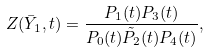Convert formula to latex. <formula><loc_0><loc_0><loc_500><loc_500>Z ( \bar { Y } _ { 1 } , t ) = \frac { P _ { 1 } ( t ) P _ { 3 } ( t ) } { P _ { 0 } ( t ) \tilde { P } _ { 2 } ( t ) P _ { 4 } ( t ) } ,</formula> 